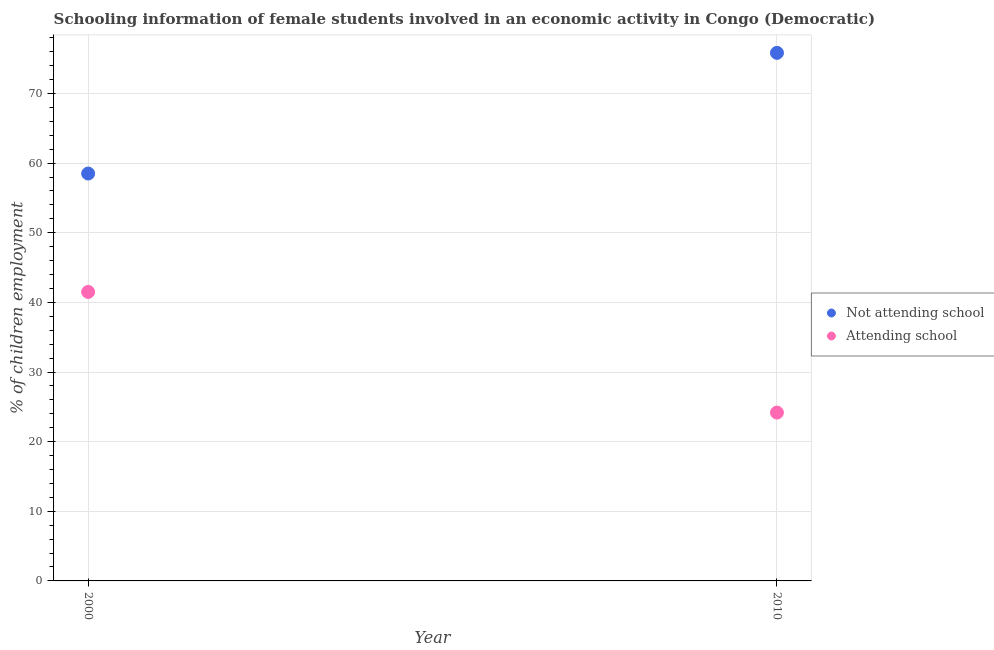How many different coloured dotlines are there?
Your response must be concise. 2. What is the percentage of employed females who are attending school in 2010?
Offer a terse response. 24.17. Across all years, what is the maximum percentage of employed females who are attending school?
Your answer should be very brief. 41.5. Across all years, what is the minimum percentage of employed females who are not attending school?
Your response must be concise. 58.5. In which year was the percentage of employed females who are not attending school maximum?
Your answer should be compact. 2010. In which year was the percentage of employed females who are attending school minimum?
Your response must be concise. 2010. What is the total percentage of employed females who are attending school in the graph?
Give a very brief answer. 65.67. What is the difference between the percentage of employed females who are attending school in 2000 and that in 2010?
Ensure brevity in your answer.  17.33. What is the difference between the percentage of employed females who are not attending school in 2010 and the percentage of employed females who are attending school in 2000?
Ensure brevity in your answer.  34.33. What is the average percentage of employed females who are not attending school per year?
Make the answer very short. 67.16. In the year 2010, what is the difference between the percentage of employed females who are attending school and percentage of employed females who are not attending school?
Offer a very short reply. -51.66. What is the ratio of the percentage of employed females who are not attending school in 2000 to that in 2010?
Offer a very short reply. 0.77. Is the percentage of employed females who are not attending school in 2000 less than that in 2010?
Give a very brief answer. Yes. Does the percentage of employed females who are not attending school monotonically increase over the years?
Your response must be concise. Yes. Is the percentage of employed females who are attending school strictly less than the percentage of employed females who are not attending school over the years?
Provide a short and direct response. Yes. How many dotlines are there?
Your answer should be very brief. 2. What is the difference between two consecutive major ticks on the Y-axis?
Give a very brief answer. 10. Are the values on the major ticks of Y-axis written in scientific E-notation?
Keep it short and to the point. No. Where does the legend appear in the graph?
Keep it short and to the point. Center right. How are the legend labels stacked?
Give a very brief answer. Vertical. What is the title of the graph?
Provide a succinct answer. Schooling information of female students involved in an economic activity in Congo (Democratic). What is the label or title of the X-axis?
Your answer should be compact. Year. What is the label or title of the Y-axis?
Offer a terse response. % of children employment. What is the % of children employment of Not attending school in 2000?
Offer a terse response. 58.5. What is the % of children employment of Attending school in 2000?
Your response must be concise. 41.5. What is the % of children employment of Not attending school in 2010?
Provide a succinct answer. 75.83. What is the % of children employment in Attending school in 2010?
Offer a terse response. 24.17. Across all years, what is the maximum % of children employment in Not attending school?
Offer a very short reply. 75.83. Across all years, what is the maximum % of children employment in Attending school?
Offer a terse response. 41.5. Across all years, what is the minimum % of children employment of Not attending school?
Provide a succinct answer. 58.5. Across all years, what is the minimum % of children employment of Attending school?
Make the answer very short. 24.17. What is the total % of children employment of Not attending school in the graph?
Keep it short and to the point. 134.33. What is the total % of children employment of Attending school in the graph?
Make the answer very short. 65.67. What is the difference between the % of children employment of Not attending school in 2000 and that in 2010?
Give a very brief answer. -17.33. What is the difference between the % of children employment of Attending school in 2000 and that in 2010?
Offer a very short reply. 17.33. What is the difference between the % of children employment of Not attending school in 2000 and the % of children employment of Attending school in 2010?
Your response must be concise. 34.33. What is the average % of children employment in Not attending school per year?
Offer a very short reply. 67.16. What is the average % of children employment in Attending school per year?
Offer a terse response. 32.84. In the year 2010, what is the difference between the % of children employment in Not attending school and % of children employment in Attending school?
Offer a terse response. 51.66. What is the ratio of the % of children employment of Not attending school in 2000 to that in 2010?
Your answer should be very brief. 0.77. What is the ratio of the % of children employment of Attending school in 2000 to that in 2010?
Ensure brevity in your answer.  1.72. What is the difference between the highest and the second highest % of children employment of Not attending school?
Your answer should be very brief. 17.33. What is the difference between the highest and the second highest % of children employment in Attending school?
Offer a very short reply. 17.33. What is the difference between the highest and the lowest % of children employment in Not attending school?
Give a very brief answer. 17.33. What is the difference between the highest and the lowest % of children employment of Attending school?
Ensure brevity in your answer.  17.33. 